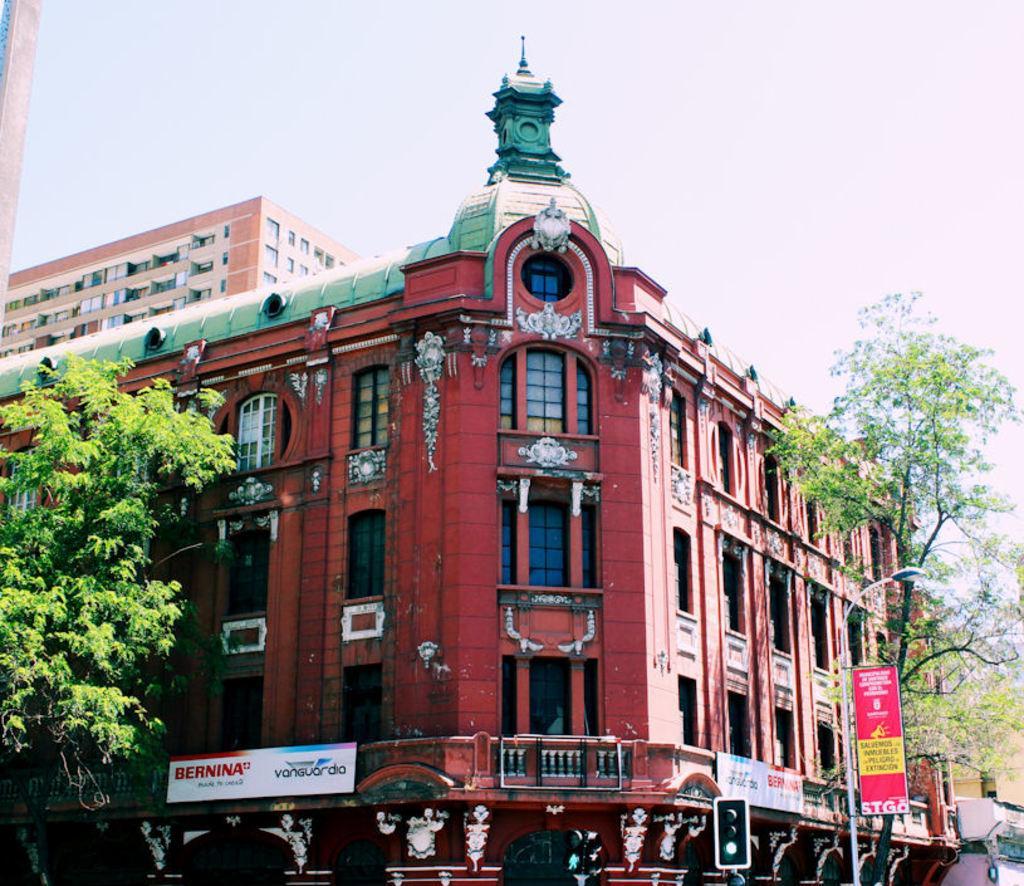Please provide a concise description of this image. In this image we can see traffic signal, pole, there are some words, we can see some trees on left and right side of the image and in the background of the image there are some buildings and top of the image there is clear sky. 